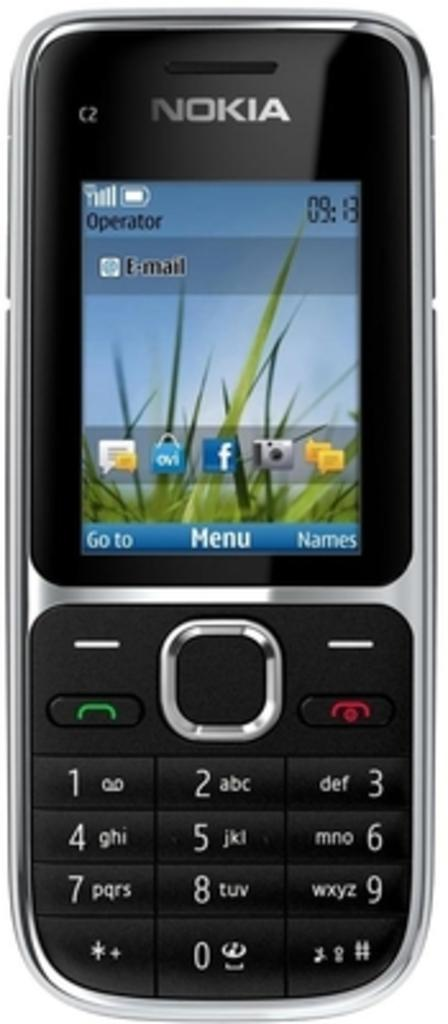<image>
Create a compact narrative representing the image presented. A phone with the capability to show emails. 